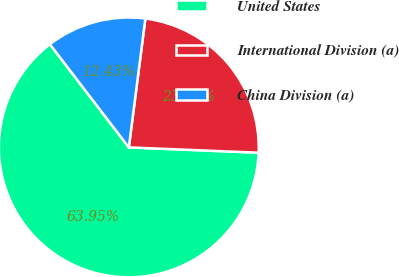<chart> <loc_0><loc_0><loc_500><loc_500><pie_chart><fcel>United States<fcel>International Division (a)<fcel>China Division (a)<nl><fcel>63.96%<fcel>23.62%<fcel>12.43%<nl></chart> 